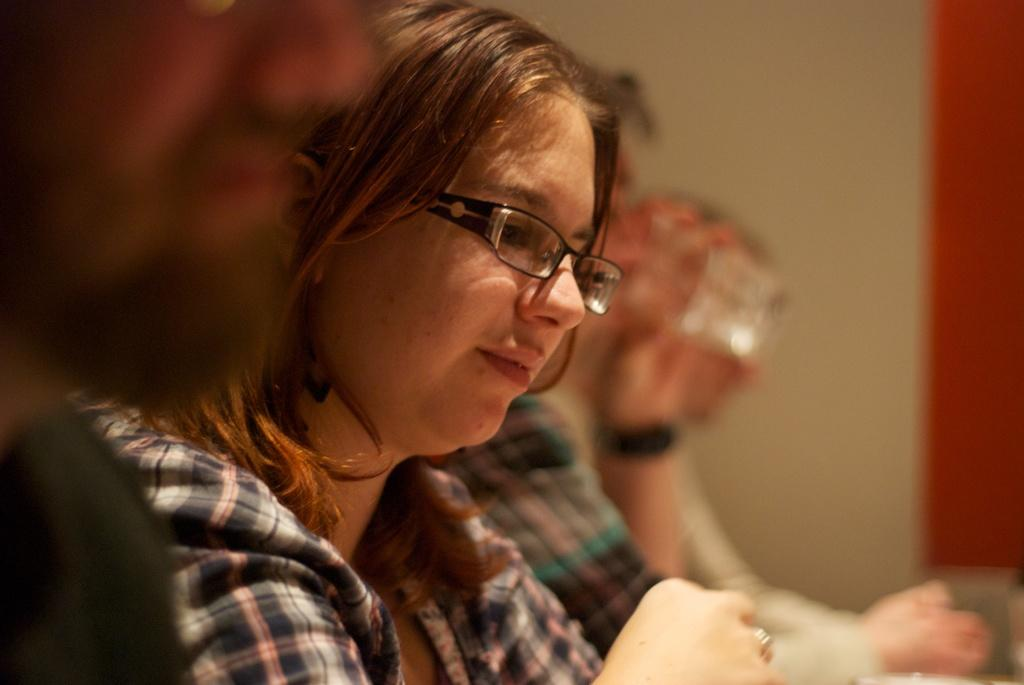Who is the main subject in the image? There is a woman in the image. What is the woman wearing on her face? The woman is wearing spectacles. Can you describe the people in the image? The people in the image are blurred. What can be seen in the background of the image? There is a wall in the background of the image. What type of sweater is the woman wearing in the image? The provided facts do not mention a sweater, so we cannot determine the type of sweater the woman is wearing in the image. 